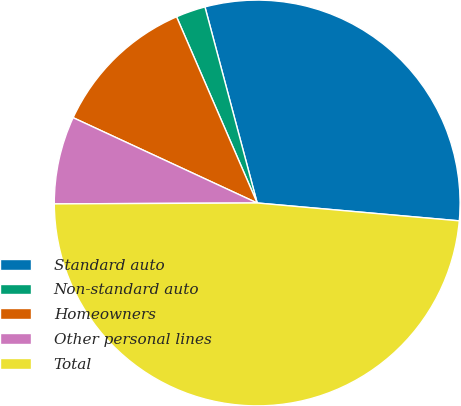<chart> <loc_0><loc_0><loc_500><loc_500><pie_chart><fcel>Standard auto<fcel>Non-standard auto<fcel>Homeowners<fcel>Other personal lines<fcel>Total<nl><fcel>30.55%<fcel>2.36%<fcel>11.59%<fcel>6.98%<fcel>48.53%<nl></chart> 